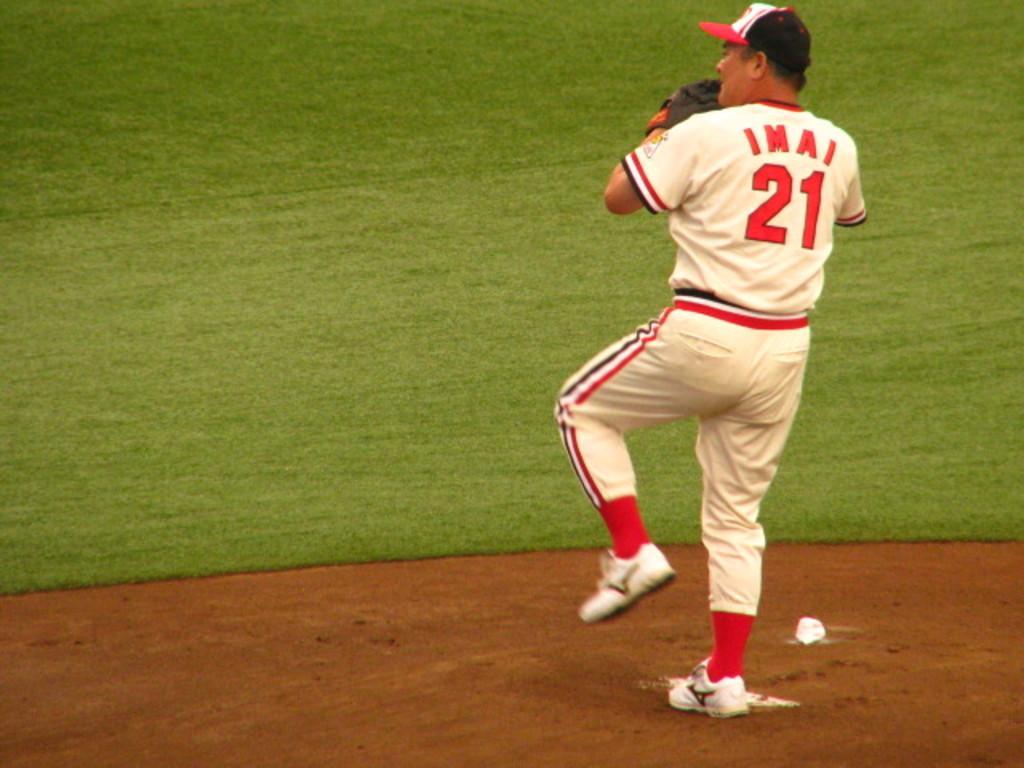How would you summarize this image in a sentence or two? In the image there is a person standing on the ground by lifting his one of the leg upwards and in front of him there is a lot of grass. 